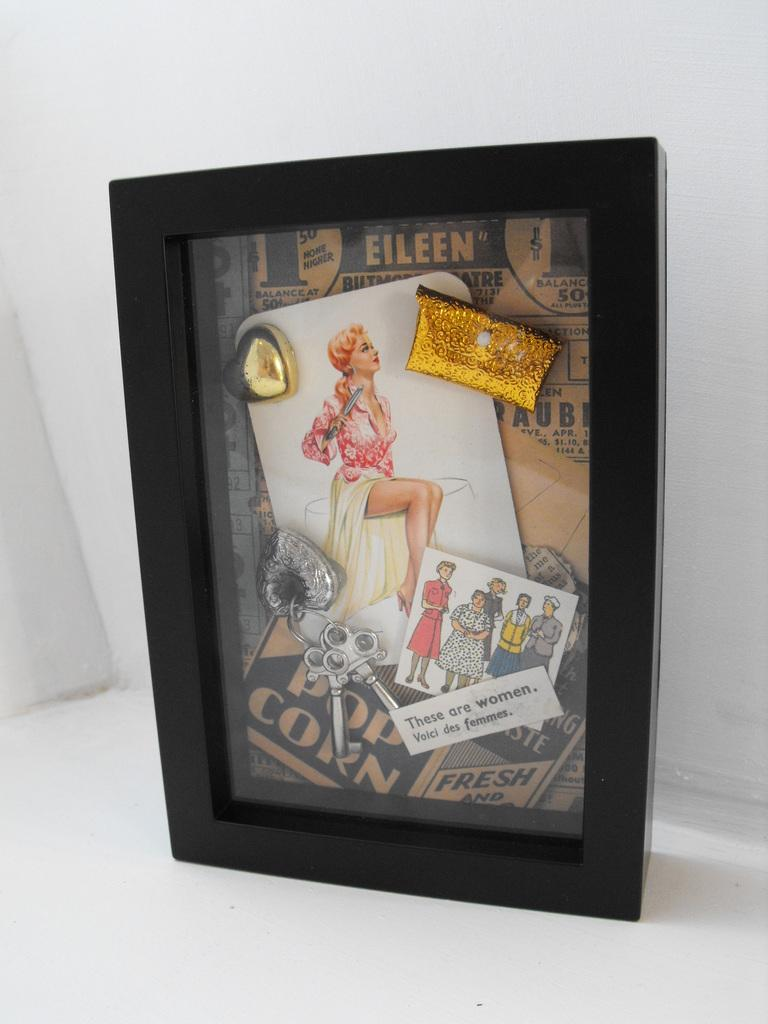Provide a one-sentence caption for the provided image. A shadow box display with a pop corn advertisement. 